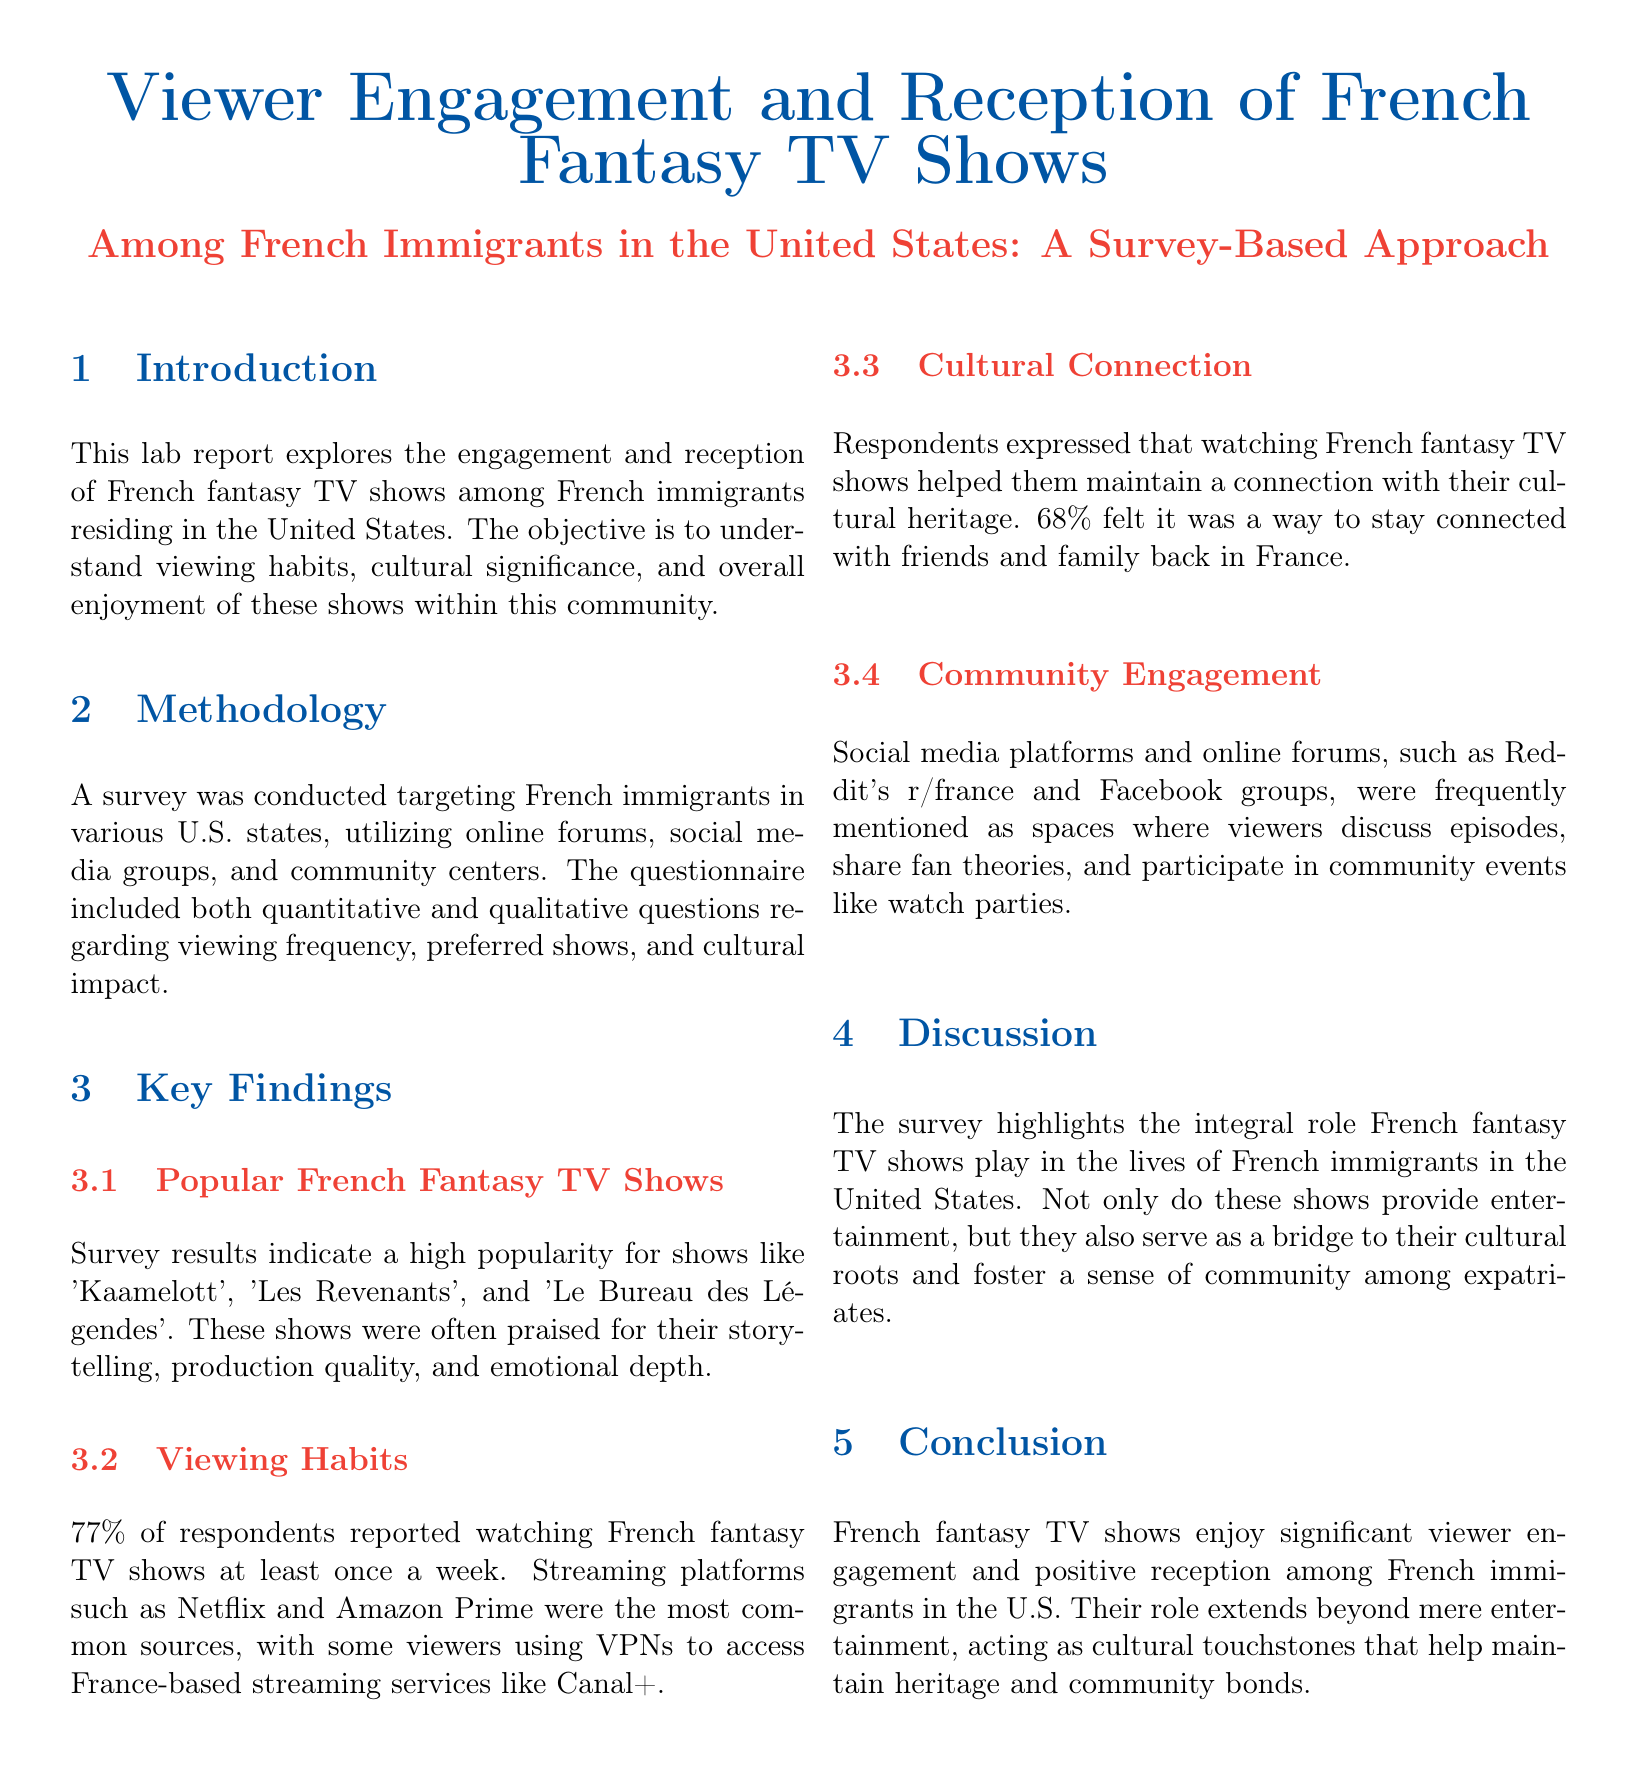what is the primary focus of the lab report? The primary focus of the lab report is exploring the engagement and reception of French fantasy TV shows among French immigrants in the United States.
Answer: engagement and reception of French fantasy TV shows what percentage of respondents watch French fantasy TV shows weekly? 77% of respondents reported watching French fantasy TV shows at least once a week.
Answer: 77% which platforms were most commonly used to watch French fantasy TV shows? Streaming platforms such as Netflix and Amazon Prime were the most common sources mentioned in the report.
Answer: Netflix and Amazon Prime what shows were identified as popular among the respondents? The survey indicated high popularity for shows like 'Kaamelott', 'Les Revenants', and 'Le Bureau des Légendes'.
Answer: 'Kaamelott', 'Les Revenants', and 'Le Bureau des Légendes' how do respondents feel about cultural connection through these shows? 68% felt that watching French fantasy TV shows helped them stay connected with their cultural heritage.
Answer: 68% what role do French fantasy TV shows play for French immigrants according to the report? The shows serve as a bridge to their cultural roots and foster a sense of community among expatriates.
Answer: bridge to cultural roots and community what community engagement platforms were mentioned in the survey findings? Social media platforms and online forums like Reddit's r/france and Facebook groups were mentioned.
Answer: Reddit's r/france and Facebook groups what is the conclusion drawn in the report about French fantasy TV shows? The conclusion states that these shows enjoy significant viewer engagement and positive reception among French immigrants in the U.S.
Answer: significant viewer engagement and positive reception 